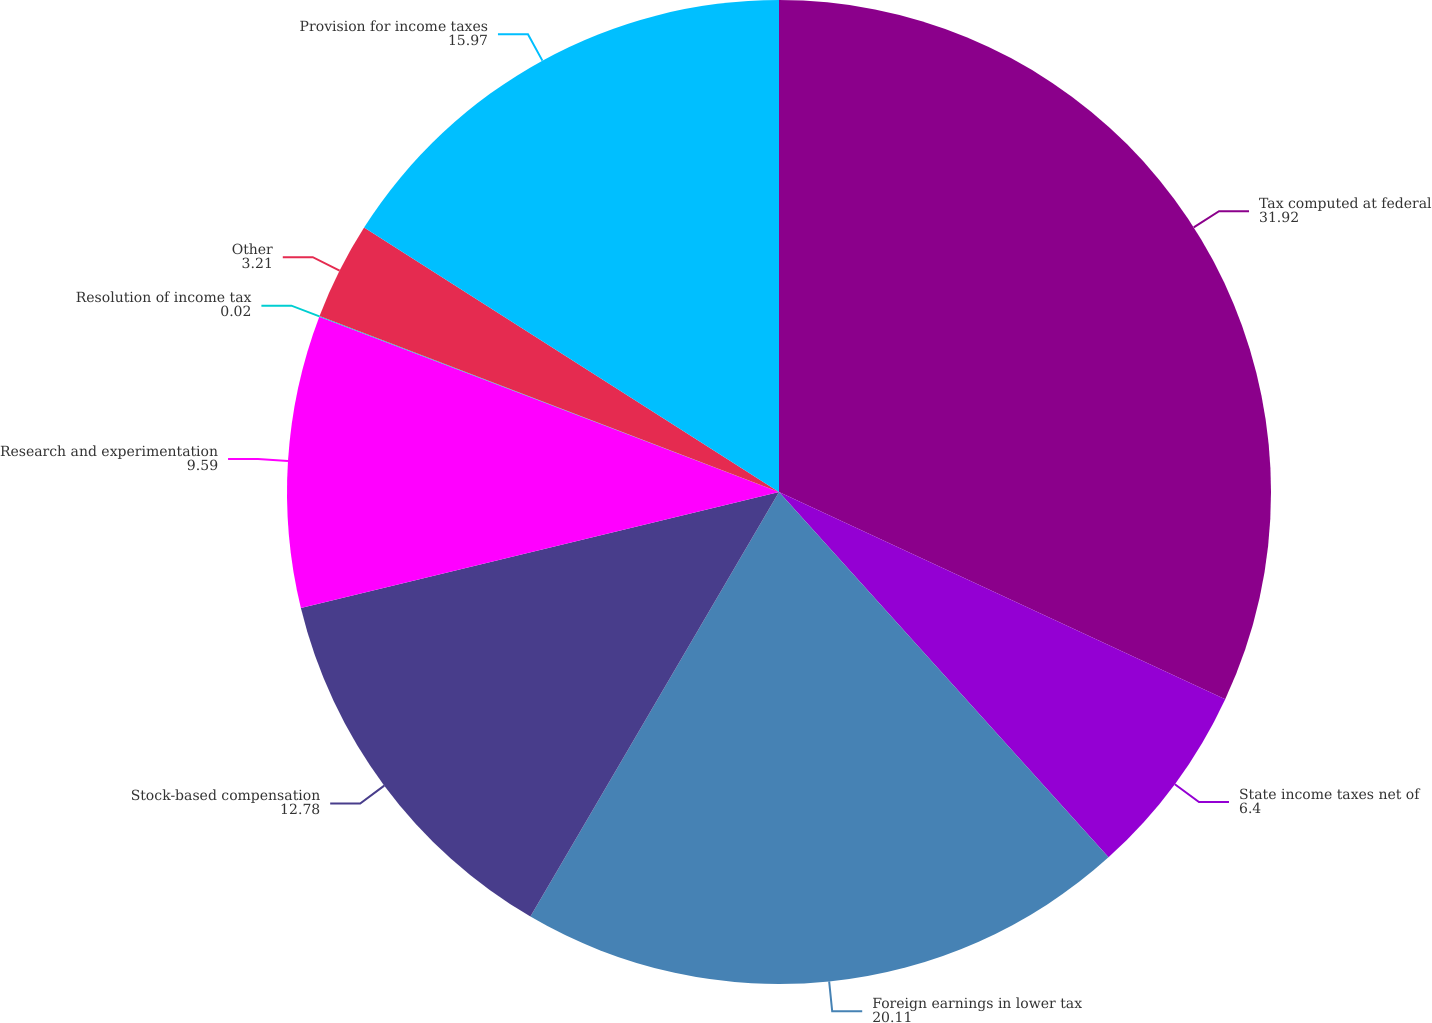Convert chart to OTSL. <chart><loc_0><loc_0><loc_500><loc_500><pie_chart><fcel>Tax computed at federal<fcel>State income taxes net of<fcel>Foreign earnings in lower tax<fcel>Stock-based compensation<fcel>Research and experimentation<fcel>Resolution of income tax<fcel>Other<fcel>Provision for income taxes<nl><fcel>31.92%<fcel>6.4%<fcel>20.11%<fcel>12.78%<fcel>9.59%<fcel>0.02%<fcel>3.21%<fcel>15.97%<nl></chart> 